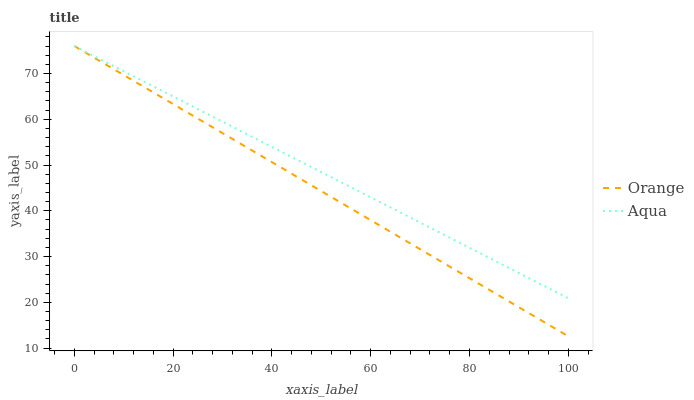Does Orange have the minimum area under the curve?
Answer yes or no. Yes. Does Aqua have the maximum area under the curve?
Answer yes or no. Yes. Does Aqua have the minimum area under the curve?
Answer yes or no. No. Is Aqua the smoothest?
Answer yes or no. Yes. Is Orange the roughest?
Answer yes or no. Yes. Is Aqua the roughest?
Answer yes or no. No. Does Orange have the lowest value?
Answer yes or no. Yes. Does Aqua have the lowest value?
Answer yes or no. No. Does Aqua have the highest value?
Answer yes or no. Yes. Does Aqua intersect Orange?
Answer yes or no. Yes. Is Aqua less than Orange?
Answer yes or no. No. Is Aqua greater than Orange?
Answer yes or no. No. 